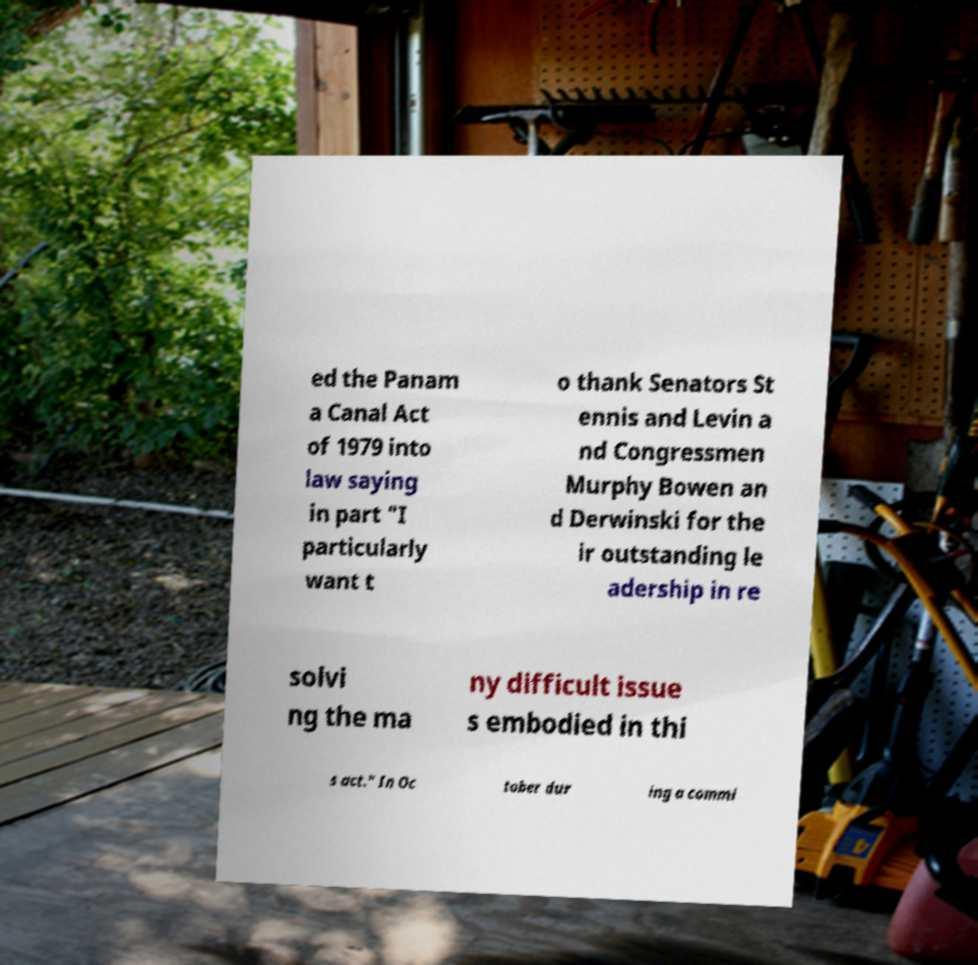Please identify and transcribe the text found in this image. ed the Panam a Canal Act of 1979 into law saying in part "I particularly want t o thank Senators St ennis and Levin a nd Congressmen Murphy Bowen an d Derwinski for the ir outstanding le adership in re solvi ng the ma ny difficult issue s embodied in thi s act." In Oc tober dur ing a commi 